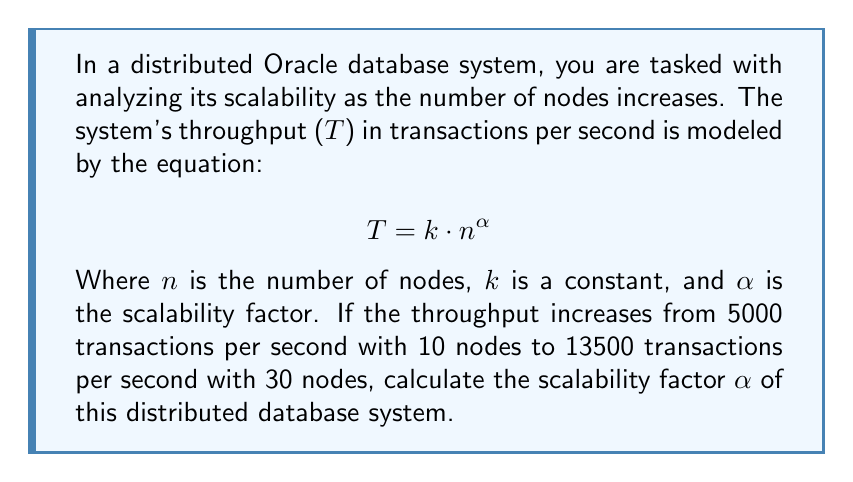Solve this math problem. To solve this problem, we'll follow these steps:

1) We have two data points:
   - When $n_1 = 10$, $T_1 = 5000$
   - When $n_2 = 30$, $T_2 = 13500$

2) We can write two equations using the given model:
   $$T_1 = k \cdot n_1^{\alpha}$$
   $$T_2 = k \cdot n_2^{\alpha}$$

3) Dividing these equations eliminates $k$:
   $$\frac{T_2}{T_1} = \frac{k \cdot n_2^{\alpha}}{k \cdot n_1^{\alpha}} = \left(\frac{n_2}{n_1}\right)^{\alpha}$$

4) Substituting the known values:
   $$\frac{13500}{5000} = \left(\frac{30}{10}\right)^{\alpha}$$

5) Simplifying:
   $$2.7 = 3^{\alpha}$$

6) Taking the natural logarithm of both sides:
   $$\ln(2.7) = \alpha \cdot \ln(3)$$

7) Solving for $\alpha$:
   $$\alpha = \frac{\ln(2.7)}{\ln(3)} \approx 0.8746$$

This value of $\alpha$ represents the scalability factor of the system.
Answer: $\alpha \approx 0.8746$ 